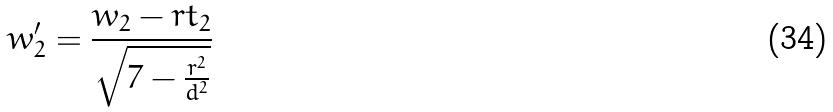<formula> <loc_0><loc_0><loc_500><loc_500>w _ { 2 } ^ { \prime } = \frac { w _ { 2 } - r t _ { 2 } } { \sqrt { 7 - \frac { r ^ { 2 } } { d ^ { 2 } } } }</formula> 